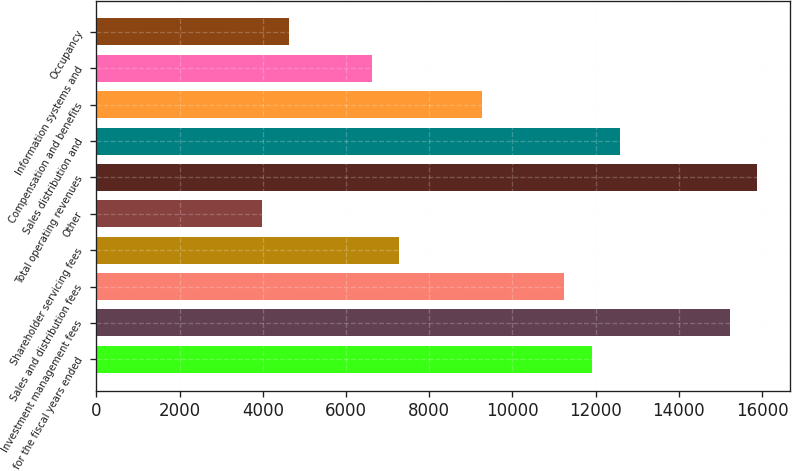Convert chart. <chart><loc_0><loc_0><loc_500><loc_500><bar_chart><fcel>for the fiscal years ended<fcel>Investment management fees<fcel>Sales and distribution fees<fcel>Shareholder servicing fees<fcel>Other<fcel>Total operating revenues<fcel>Sales distribution and<fcel>Compensation and benefits<fcel>Information systems and<fcel>Occupancy<nl><fcel>11911.9<fcel>15220.5<fcel>11250.1<fcel>7279.75<fcel>3971.1<fcel>15882.2<fcel>12573.6<fcel>9264.94<fcel>6618.02<fcel>4632.83<nl></chart> 